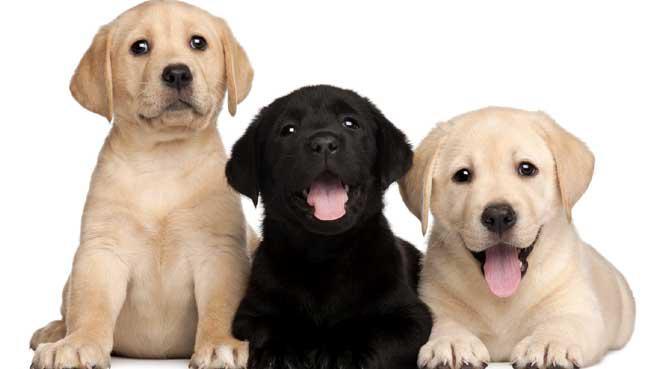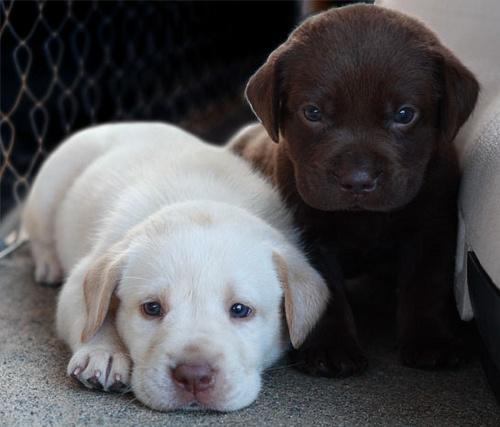The first image is the image on the left, the second image is the image on the right. Considering the images on both sides, is "An image shows a row of three dogs, with a black one in the middle." valid? Answer yes or no. Yes. The first image is the image on the left, the second image is the image on the right. Analyze the images presented: Is the assertion "There are four dogs." valid? Answer yes or no. No. 